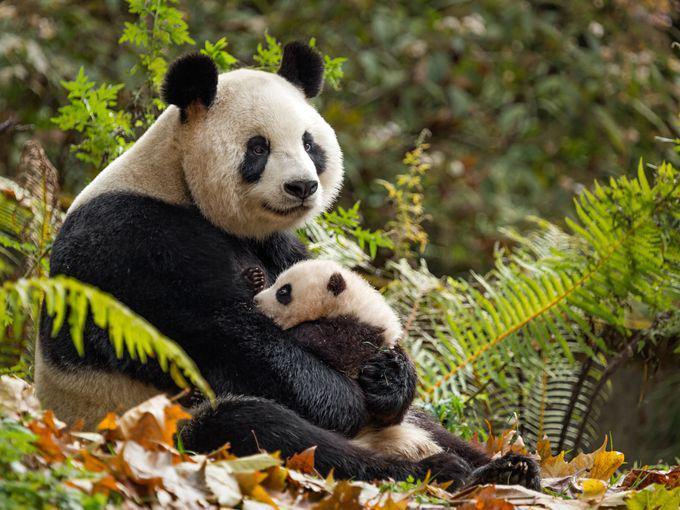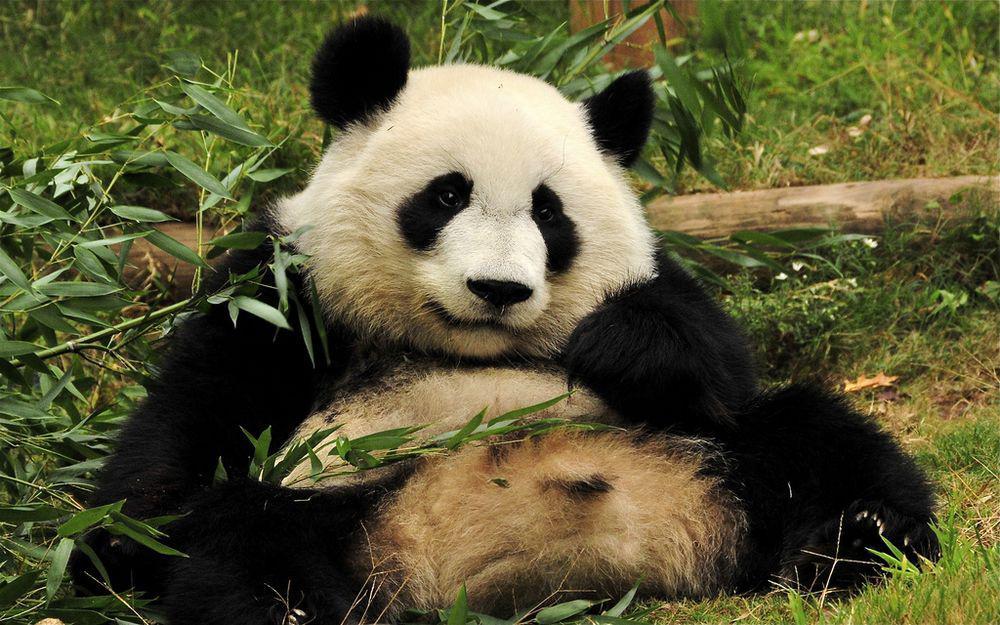The first image is the image on the left, the second image is the image on the right. For the images displayed, is the sentence "One image contains twice as many pandas as the other image and features two pandas facing generally toward each other." factually correct? Answer yes or no. Yes. The first image is the image on the left, the second image is the image on the right. Considering the images on both sides, is "There are at most two panda bears." valid? Answer yes or no. No. 